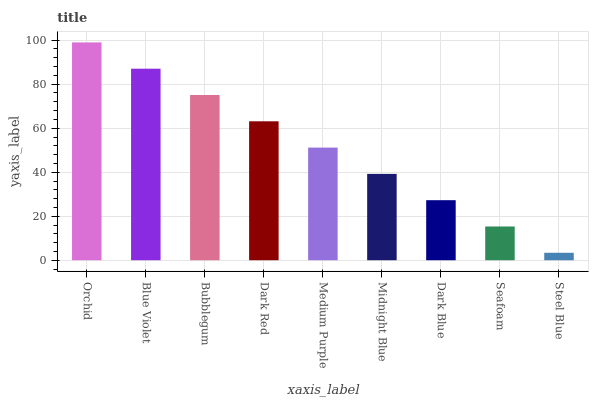Is Blue Violet the minimum?
Answer yes or no. No. Is Blue Violet the maximum?
Answer yes or no. No. Is Orchid greater than Blue Violet?
Answer yes or no. Yes. Is Blue Violet less than Orchid?
Answer yes or no. Yes. Is Blue Violet greater than Orchid?
Answer yes or no. No. Is Orchid less than Blue Violet?
Answer yes or no. No. Is Medium Purple the high median?
Answer yes or no. Yes. Is Medium Purple the low median?
Answer yes or no. Yes. Is Orchid the high median?
Answer yes or no. No. Is Seafoam the low median?
Answer yes or no. No. 